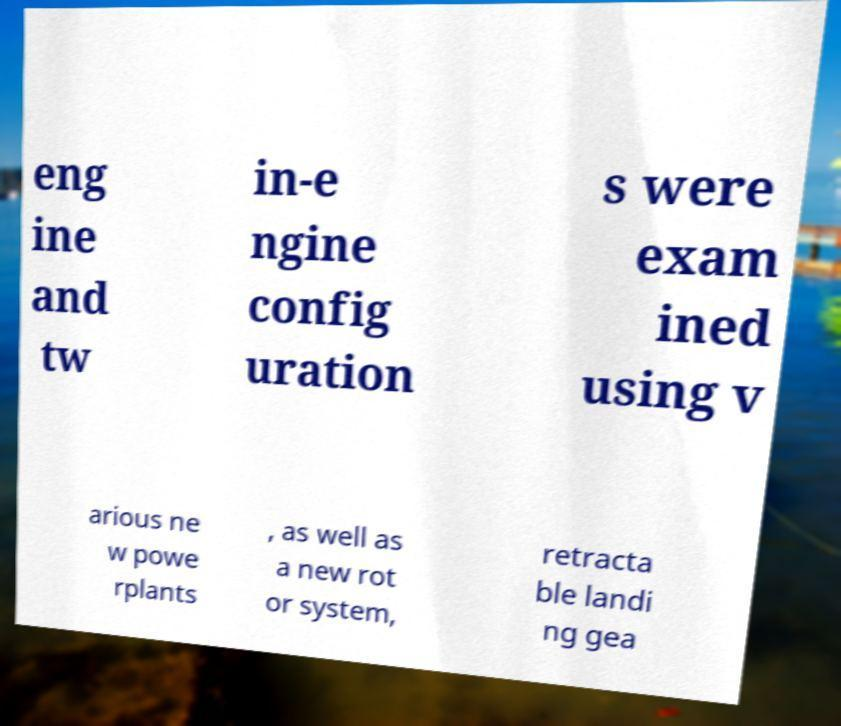Can you accurately transcribe the text from the provided image for me? eng ine and tw in-e ngine config uration s were exam ined using v arious ne w powe rplants , as well as a new rot or system, retracta ble landi ng gea 